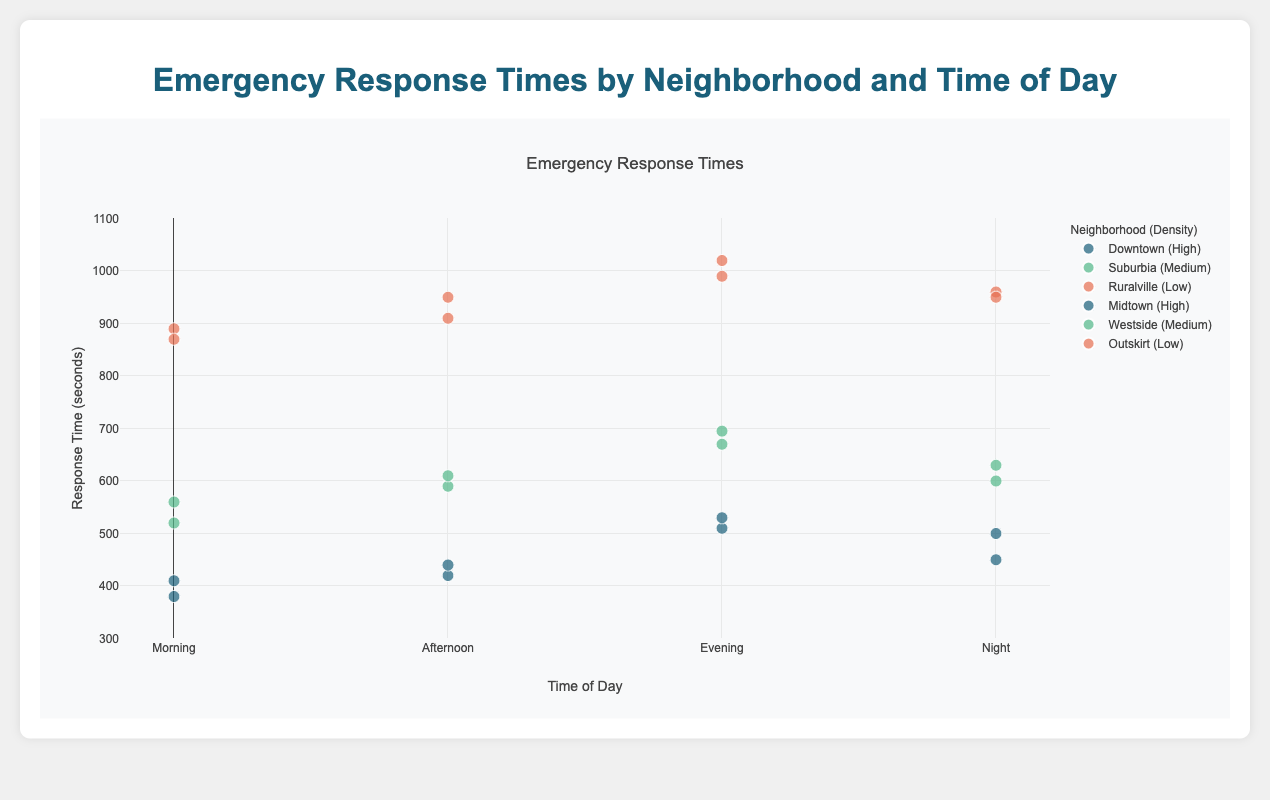What is the title of the figure? The title is the text placed at the top center of the figure, indicating the main topic or focus of the plot.
Answer: Emergency Response Times by Neighborhood and Time of Day What are the labels for the x-axis and y-axis? The x-axis label can be found below the x-axis, indicating what the horizontal axis represents, and the y-axis label can be found next to the y-axis, indicating what the vertical axis represents.
Answer: Time of Day, Response Time (seconds) Which neighborhood had the highest response time in the Evening? Look for the point on the scatter plot with the highest y-value in the Evening category, identified by the label text.
Answer: Ruralville On average, do neighborhoods with high density have faster response times than those with low density? Calculate the average response time for neighborhoods with high density and compare it to the average response time for neighborhoods with low density. High density neighborhoods (Downtown, Midtown): (380+420+510+450+410+440+530+500) / 8 = 455. Low density neighborhoods (Ruralville, Outskirt): (890 + 950 + 1020 + 960+ 870 + 910 + 990 + 950) / 8 = 942.5
Answer: Yes During which time of day does the Midtown neighborhood have the fastest response time? Identify the data points for the Midtown neighborhood and compare their y-values, selecting the lowest y-value (fastest response time).
Answer: Morning What is the difference in response time between Downtown and Suburbia during the Night? Subtract the response time of Downtown during Night from Suburbia during Night. Downtown (450 seconds), Suburbia (600 seconds), 600 - 450 = 150 seconds
Answer: 150 seconds Which neighborhood has the most significant increase in response time from Morning to Evening? For each neighborhood, calculate the difference in response time between the Morning and Evening. Identify the neighborhood with the highest difference. Ruralville (1020 - 890 = 130), Outskirt (990 - 870 = 120), Downtown (510 - 380 = 130), Midtown (530 - 410 = 120), Suburbia (670 - 520 = 150), Westside (695 - 560 = 135)
Answer: Suburbia How do response times generally vary by time of day across all neighborhoods? Observe the general trend for response times (y-values) across the four time points on the x-axis (Morning, Afternoon, Evening, Night). Morning is generally lowest, increasing throughout the day.
Answer: They increase Which neighborhood and time of day combination has the lowest response time among medium-density areas? Identify all medium-density data points and find the one with the lowest y-value. Suburbia Morning (520), Suburbia Afternoon (590), Suburbia Evening (670), Suburbia Night (600), Westside Morning (560), Westside Afternoon (610), Westside Evening (695), Westside Night (630).
Answer: Suburbia Morning Comparing Evening time, which density group generally has higher response times? Compare the y-values for High, Medium, and Low-density groups in the Evening category. High (Downtown: 510, Midtown: 530), Medium (Suburbia: 670, Westside: 695), Low (Ruralville: 1020, Outskirt: 990).
Answer: Low density 